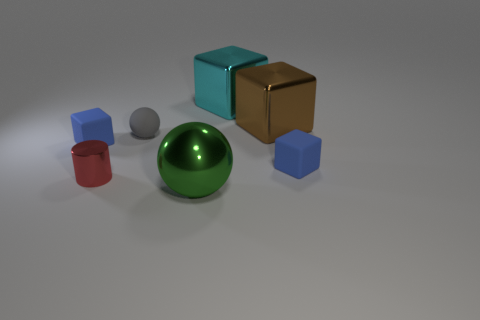Subtract all brown blocks. How many blocks are left? 3 Add 3 tiny gray rubber objects. How many objects exist? 10 Subtract 1 cylinders. How many cylinders are left? 0 Subtract all cyan balls. How many blue blocks are left? 2 Subtract all brown blocks. How many blocks are left? 3 Subtract all balls. How many objects are left? 5 Subtract all blue spheres. Subtract all brown cylinders. How many spheres are left? 2 Subtract all large brown objects. Subtract all red objects. How many objects are left? 5 Add 7 gray matte balls. How many gray matte balls are left? 8 Add 5 blue rubber cubes. How many blue rubber cubes exist? 7 